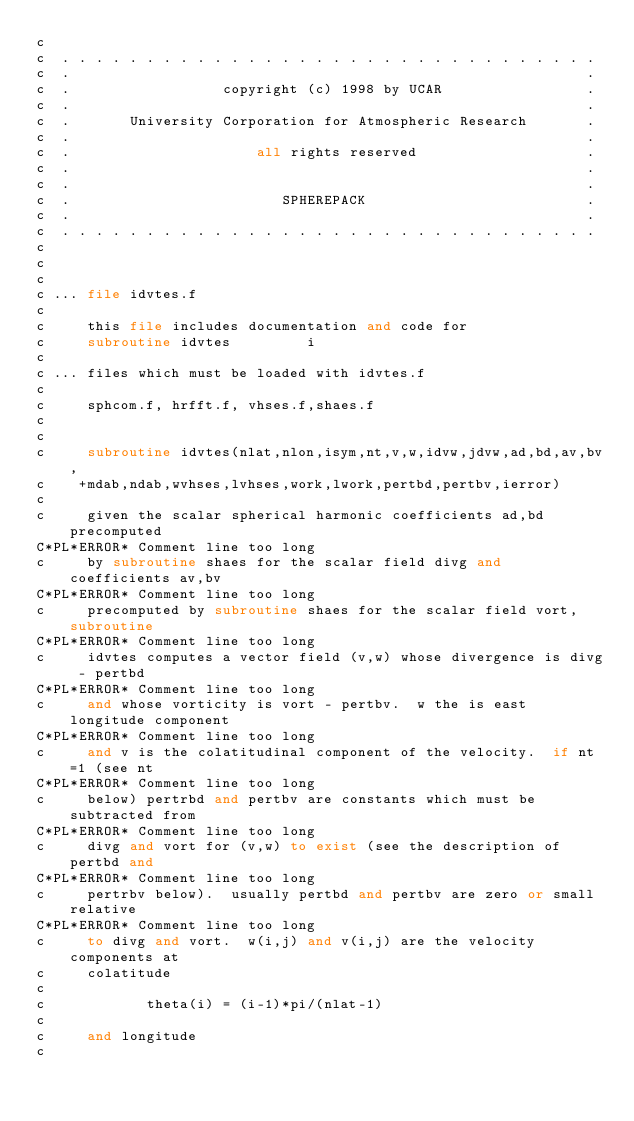<code> <loc_0><loc_0><loc_500><loc_500><_FORTRAN_>c
c  . . . . . . . . . . . . . . . . . . . . . . . . . . . . . . . .
c  .                                                             .
c  .                  copyright (c) 1998 by UCAR                 .
c  .                                                             .
c  .       University Corporation for Atmospheric Research       .
c  .                                                             .
c  .                      all rights reserved                    .
c  .                                                             .
c  .                                                             .
c  .                         SPHEREPACK                          .
c  .                                                             .
c  . . . . . . . . . . . . . . . . . . . . . . . . . . . . . . . .
c
c
c
c ... file idvtes.f
c
c     this file includes documentation and code for
c     subroutine idvtes         i
c
c ... files which must be loaded with idvtes.f
c
c     sphcom.f, hrfft.f, vhses.f,shaes.f
c
c
c     subroutine idvtes(nlat,nlon,isym,nt,v,w,idvw,jdvw,ad,bd,av,bv,
c    +mdab,ndab,wvhses,lvhses,work,lwork,pertbd,pertbv,ierror)
c
c     given the scalar spherical harmonic coefficients ad,bd precomputed
C*PL*ERROR* Comment line too long
c     by subroutine shaes for the scalar field divg and coefficients av,bv
C*PL*ERROR* Comment line too long
c     precomputed by subroutine shaes for the scalar field vort, subroutine
C*PL*ERROR* Comment line too long
c     idvtes computes a vector field (v,w) whose divergence is divg - pertbd
C*PL*ERROR* Comment line too long
c     and whose vorticity is vort - pertbv.  w the is east longitude component
C*PL*ERROR* Comment line too long
c     and v is the colatitudinal component of the velocity.  if nt=1 (see nt
C*PL*ERROR* Comment line too long
c     below) pertrbd and pertbv are constants which must be subtracted from
C*PL*ERROR* Comment line too long
c     divg and vort for (v,w) to exist (see the description of pertbd and
C*PL*ERROR* Comment line too long
c     pertrbv below).  usually pertbd and pertbv are zero or small relative
C*PL*ERROR* Comment line too long
c     to divg and vort.  w(i,j) and v(i,j) are the velocity components at
c     colatitude
c
c            theta(i) = (i-1)*pi/(nlat-1)
c
c     and longitude
c</code> 